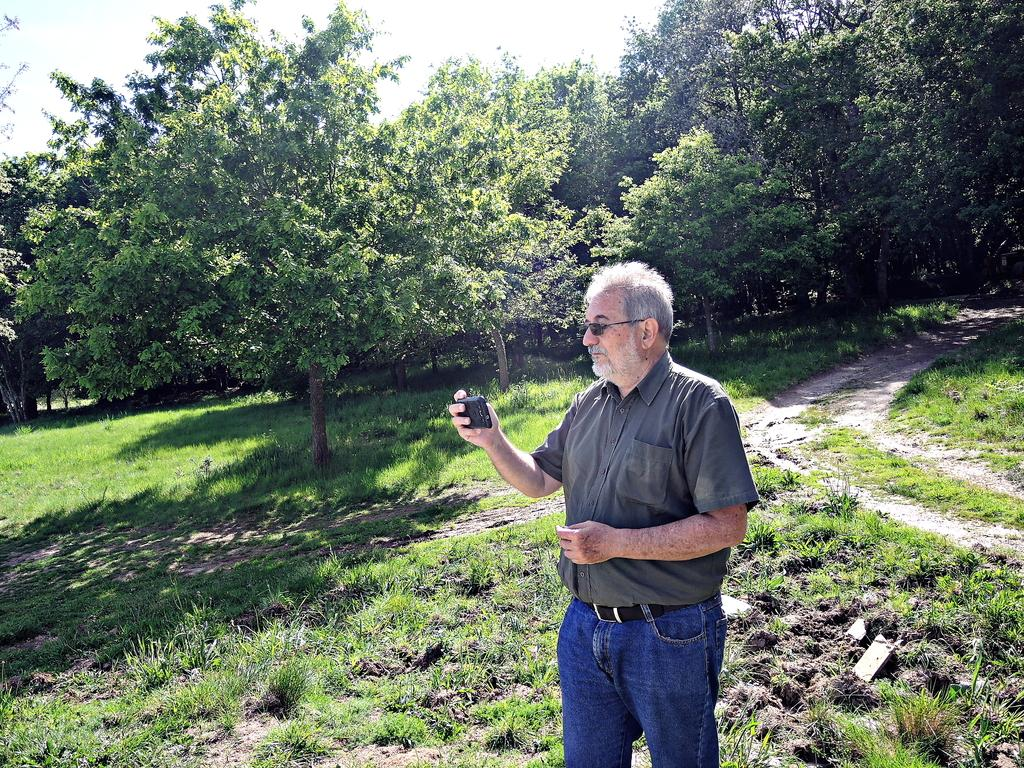Who is the main subject of the subject in the image? There is a person in the center of the image. What is the person holding in his hand? The person is holding a phone in his hand. What type of terrain is visible at the bottom of the image? There is grass at the bottom of the image. What can be seen in the background of the image? There are trees in the background of the image. What voice can be heard coming from the trees in the image? There is no voice coming from the trees in the image; it is a visual representation only. 